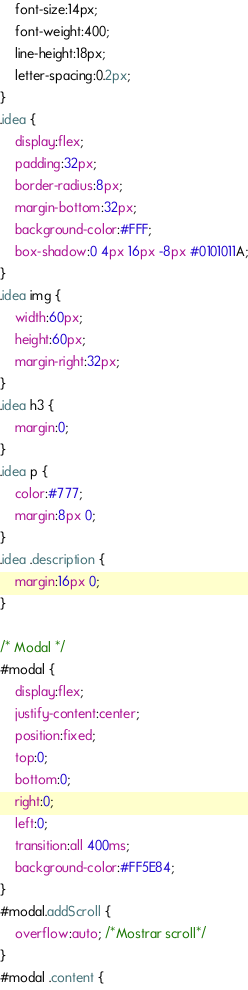<code> <loc_0><loc_0><loc_500><loc_500><_CSS_>    font-size:14px;
    font-weight:400;
    line-height:18px;
    letter-spacing:0.2px;
}
.idea {
    display:flex;
    padding:32px;
    border-radius:8px;
    margin-bottom:32px;
    background-color:#FFF;
    box-shadow:0 4px 16px -8px #0101011A;
}
.idea img {
    width:60px;
    height:60px;
    margin-right:32px;
}
.idea h3 {
    margin:0;
}
.idea p {
    color:#777;
    margin:8px 0;
}
.idea .description {
    margin:16px 0;
}

/* Modal */
#modal {
    display:flex;
    justify-content:center;
    position:fixed;
    top:0;
    bottom:0;
    right:0;
    left:0;
    transition:all 400ms;
    background-color:#FF5E84;
}
#modal.addScroll {
    overflow:auto; /*Mostrar scroll*/
}
#modal .content {</code> 